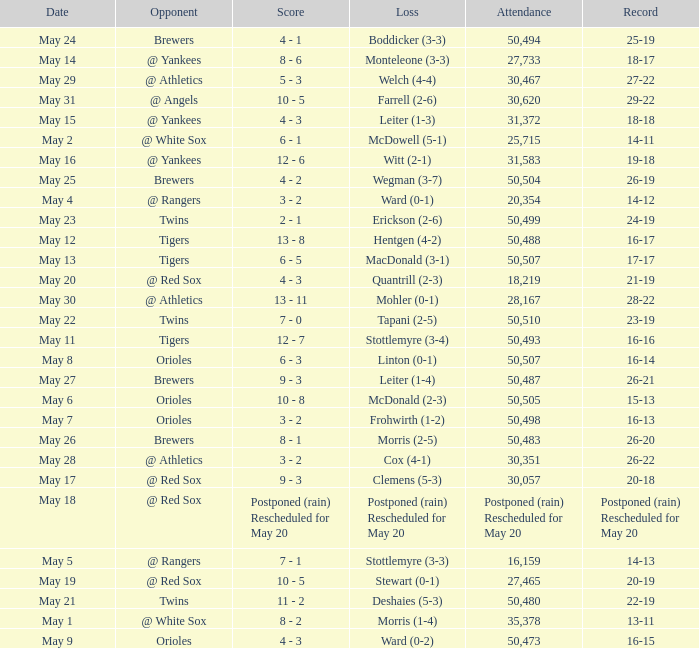On what date was their record 26-19? May 25. 